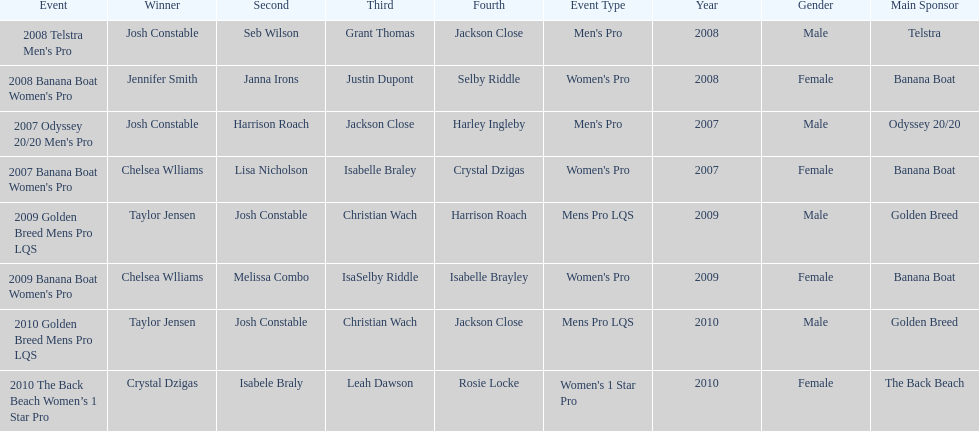At which event did taylor jensen first win? 2009 Golden Breed Mens Pro LQS. 